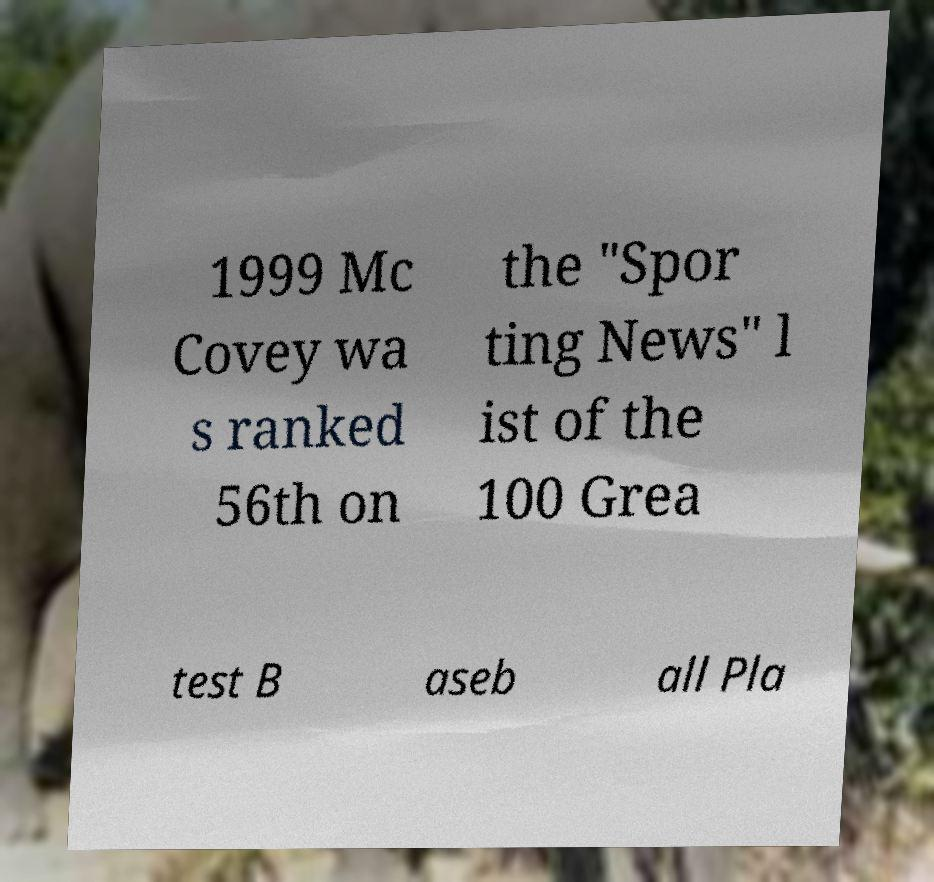There's text embedded in this image that I need extracted. Can you transcribe it verbatim? 1999 Mc Covey wa s ranked 56th on the "Spor ting News" l ist of the 100 Grea test B aseb all Pla 